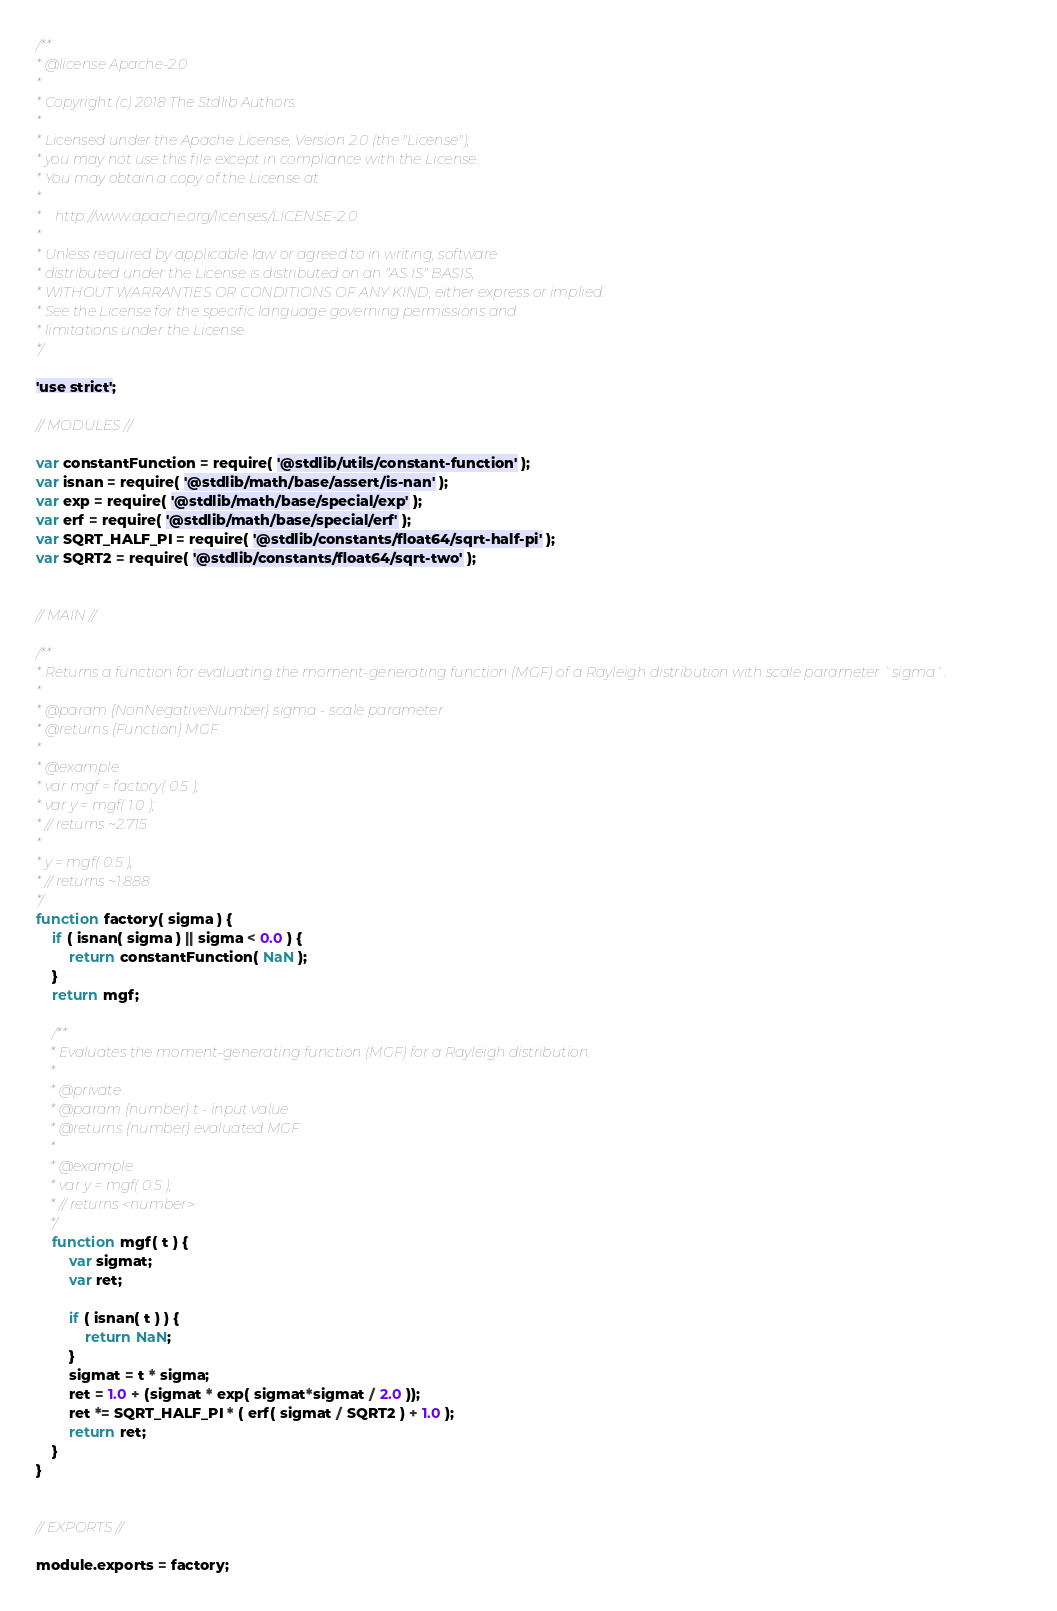<code> <loc_0><loc_0><loc_500><loc_500><_JavaScript_>/**
* @license Apache-2.0
*
* Copyright (c) 2018 The Stdlib Authors.
*
* Licensed under the Apache License, Version 2.0 (the "License");
* you may not use this file except in compliance with the License.
* You may obtain a copy of the License at
*
*    http://www.apache.org/licenses/LICENSE-2.0
*
* Unless required by applicable law or agreed to in writing, software
* distributed under the License is distributed on an "AS IS" BASIS,
* WITHOUT WARRANTIES OR CONDITIONS OF ANY KIND, either express or implied.
* See the License for the specific language governing permissions and
* limitations under the License.
*/

'use strict';

// MODULES //

var constantFunction = require( '@stdlib/utils/constant-function' );
var isnan = require( '@stdlib/math/base/assert/is-nan' );
var exp = require( '@stdlib/math/base/special/exp' );
var erf = require( '@stdlib/math/base/special/erf' );
var SQRT_HALF_PI = require( '@stdlib/constants/float64/sqrt-half-pi' );
var SQRT2 = require( '@stdlib/constants/float64/sqrt-two' );


// MAIN //

/**
* Returns a function for evaluating the moment-generating function (MGF) of a Rayleigh distribution with scale parameter `sigma`.
*
* @param {NonNegativeNumber} sigma - scale parameter
* @returns {Function} MGF
*
* @example
* var mgf = factory( 0.5 );
* var y = mgf( 1.0 );
* // returns ~2.715
*
* y = mgf( 0.5 );
* // returns ~1.888
*/
function factory( sigma ) {
	if ( isnan( sigma ) || sigma < 0.0 ) {
		return constantFunction( NaN );
	}
	return mgf;

	/**
	* Evaluates the moment-generating function (MGF) for a Rayleigh distribution.
	*
	* @private
	* @param {number} t - input value
	* @returns {number} evaluated MGF
	*
	* @example
	* var y = mgf( 0.5 );
	* // returns <number>
	*/
	function mgf( t ) {
		var sigmat;
		var ret;

		if ( isnan( t ) ) {
			return NaN;
		}
		sigmat = t * sigma;
		ret = 1.0 + (sigmat * exp( sigmat*sigmat / 2.0 ));
		ret *= SQRT_HALF_PI * ( erf( sigmat / SQRT2 ) + 1.0 );
		return ret;
	}
}


// EXPORTS //

module.exports = factory;
</code> 